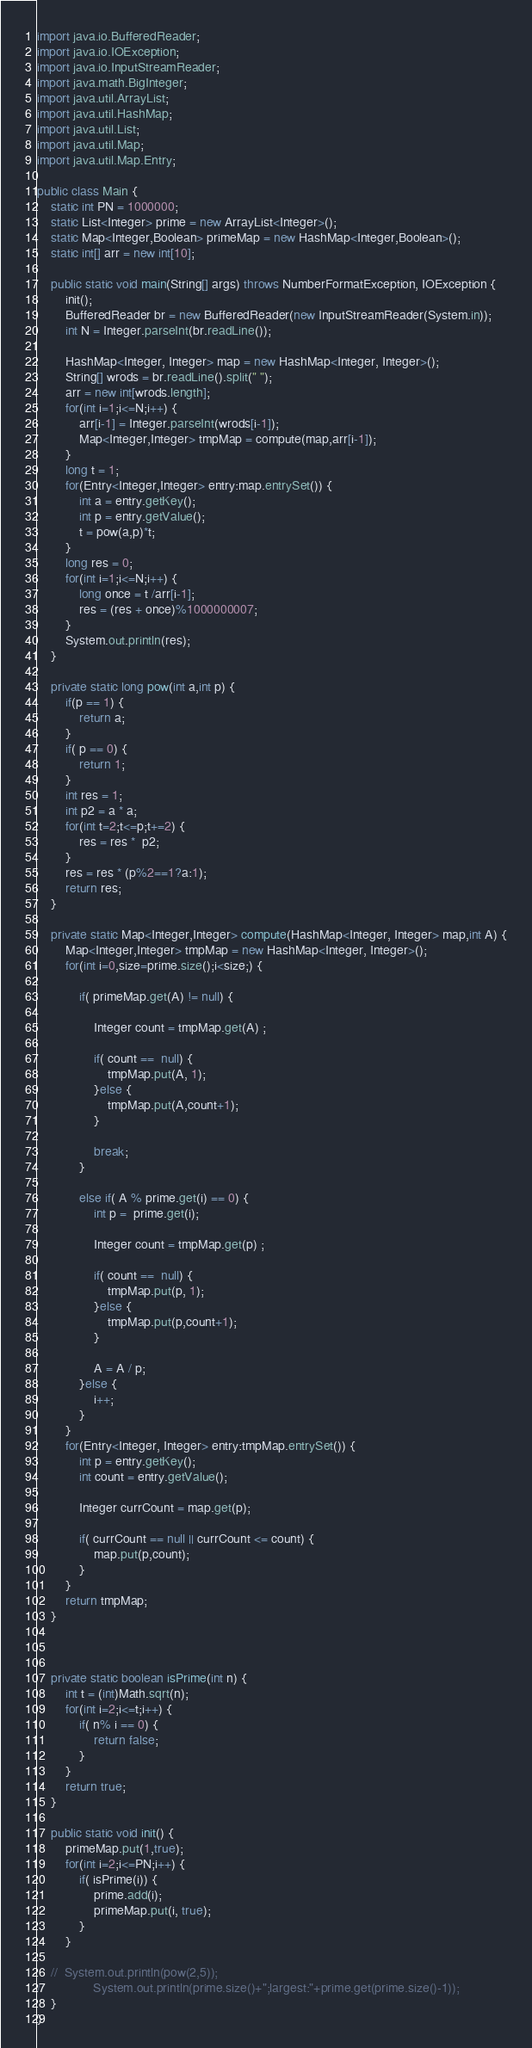<code> <loc_0><loc_0><loc_500><loc_500><_Java_>import java.io.BufferedReader;
import java.io.IOException;
import java.io.InputStreamReader;
import java.math.BigInteger;
import java.util.ArrayList;
import java.util.HashMap;
import java.util.List;
import java.util.Map;
import java.util.Map.Entry;

public class Main {
	static int PN = 1000000;
	static List<Integer> prime = new ArrayList<Integer>();
	static Map<Integer,Boolean> primeMap = new HashMap<Integer,Boolean>();
	static int[] arr = new int[10];
	
	public static void main(String[] args) throws NumberFormatException, IOException {
		init();
		BufferedReader br = new BufferedReader(new InputStreamReader(System.in));
		int N = Integer.parseInt(br.readLine());
		
		HashMap<Integer, Integer> map = new HashMap<Integer, Integer>();
		String[] wrods = br.readLine().split(" ");
		arr = new int[wrods.length];
		for(int i=1;i<=N;i++) {
			arr[i-1] = Integer.parseInt(wrods[i-1]);
			Map<Integer,Integer> tmpMap = compute(map,arr[i-1]);
		}
		long t = 1;
		for(Entry<Integer,Integer> entry:map.entrySet()) {
			int a = entry.getKey();
			int p = entry.getValue();
			t = pow(a,p)*t;
		}
		long res = 0;
		for(int i=1;i<=N;i++) {
			long once = t /arr[i-1]; 
			res = (res + once)%1000000007;
		}
		System.out.println(res);
	}
	
	private static long pow(int a,int p) {
		if(p == 1) {
			return a;
		}
		if( p == 0) {
			return 1;
		}
		int res = 1;
		int p2 = a * a;
		for(int t=2;t<=p;t+=2) {
			res = res *  p2;
		}
		res = res * (p%2==1?a:1);
		return res;
	}
	
	private static Map<Integer,Integer> compute(HashMap<Integer, Integer> map,int A) {
		Map<Integer,Integer> tmpMap = new HashMap<Integer, Integer>();
		for(int i=0,size=prime.size();i<size;) {
			
			if( primeMap.get(A) != null) {

				Integer count = tmpMap.get(A) ;
				
				if( count ==  null) {
					tmpMap.put(A, 1);
				}else {
					tmpMap.put(A,count+1);
				}
				
				break;
			}
			
			else if( A % prime.get(i) == 0) {
				int p =  prime.get(i);
				
				Integer count = tmpMap.get(p) ;
				
				if( count ==  null) {
					tmpMap.put(p, 1);
				}else {
					tmpMap.put(p,count+1);
				}
				
				A = A / p;
			}else {
				i++;
			}
		}
		for(Entry<Integer, Integer> entry:tmpMap.entrySet()) {
			int p = entry.getKey();
			int count = entry.getValue();
			
			Integer currCount = map.get(p);
			
			if( currCount == null || currCount <= count) {
				map.put(p,count);
			}
		}
		return tmpMap;
	}
	
	
	
	private static boolean isPrime(int n) {
		int t = (int)Math.sqrt(n);
		for(int i=2;i<=t;i++) {
			if( n% i == 0) {
				return false;
			}
		}
		return true;
	}
	
	public static void init() {
		primeMap.put(1,true);
		for(int i=2;i<=PN;i++) {
			if( isPrime(i)) {
				prime.add(i);
				primeMap.put(i, true);
			}
		}
		
	//	System.out.println(pow(2,5));
//				System.out.println(prime.size()+";largest:"+prime.get(prime.size()-1));
	}
}
</code> 